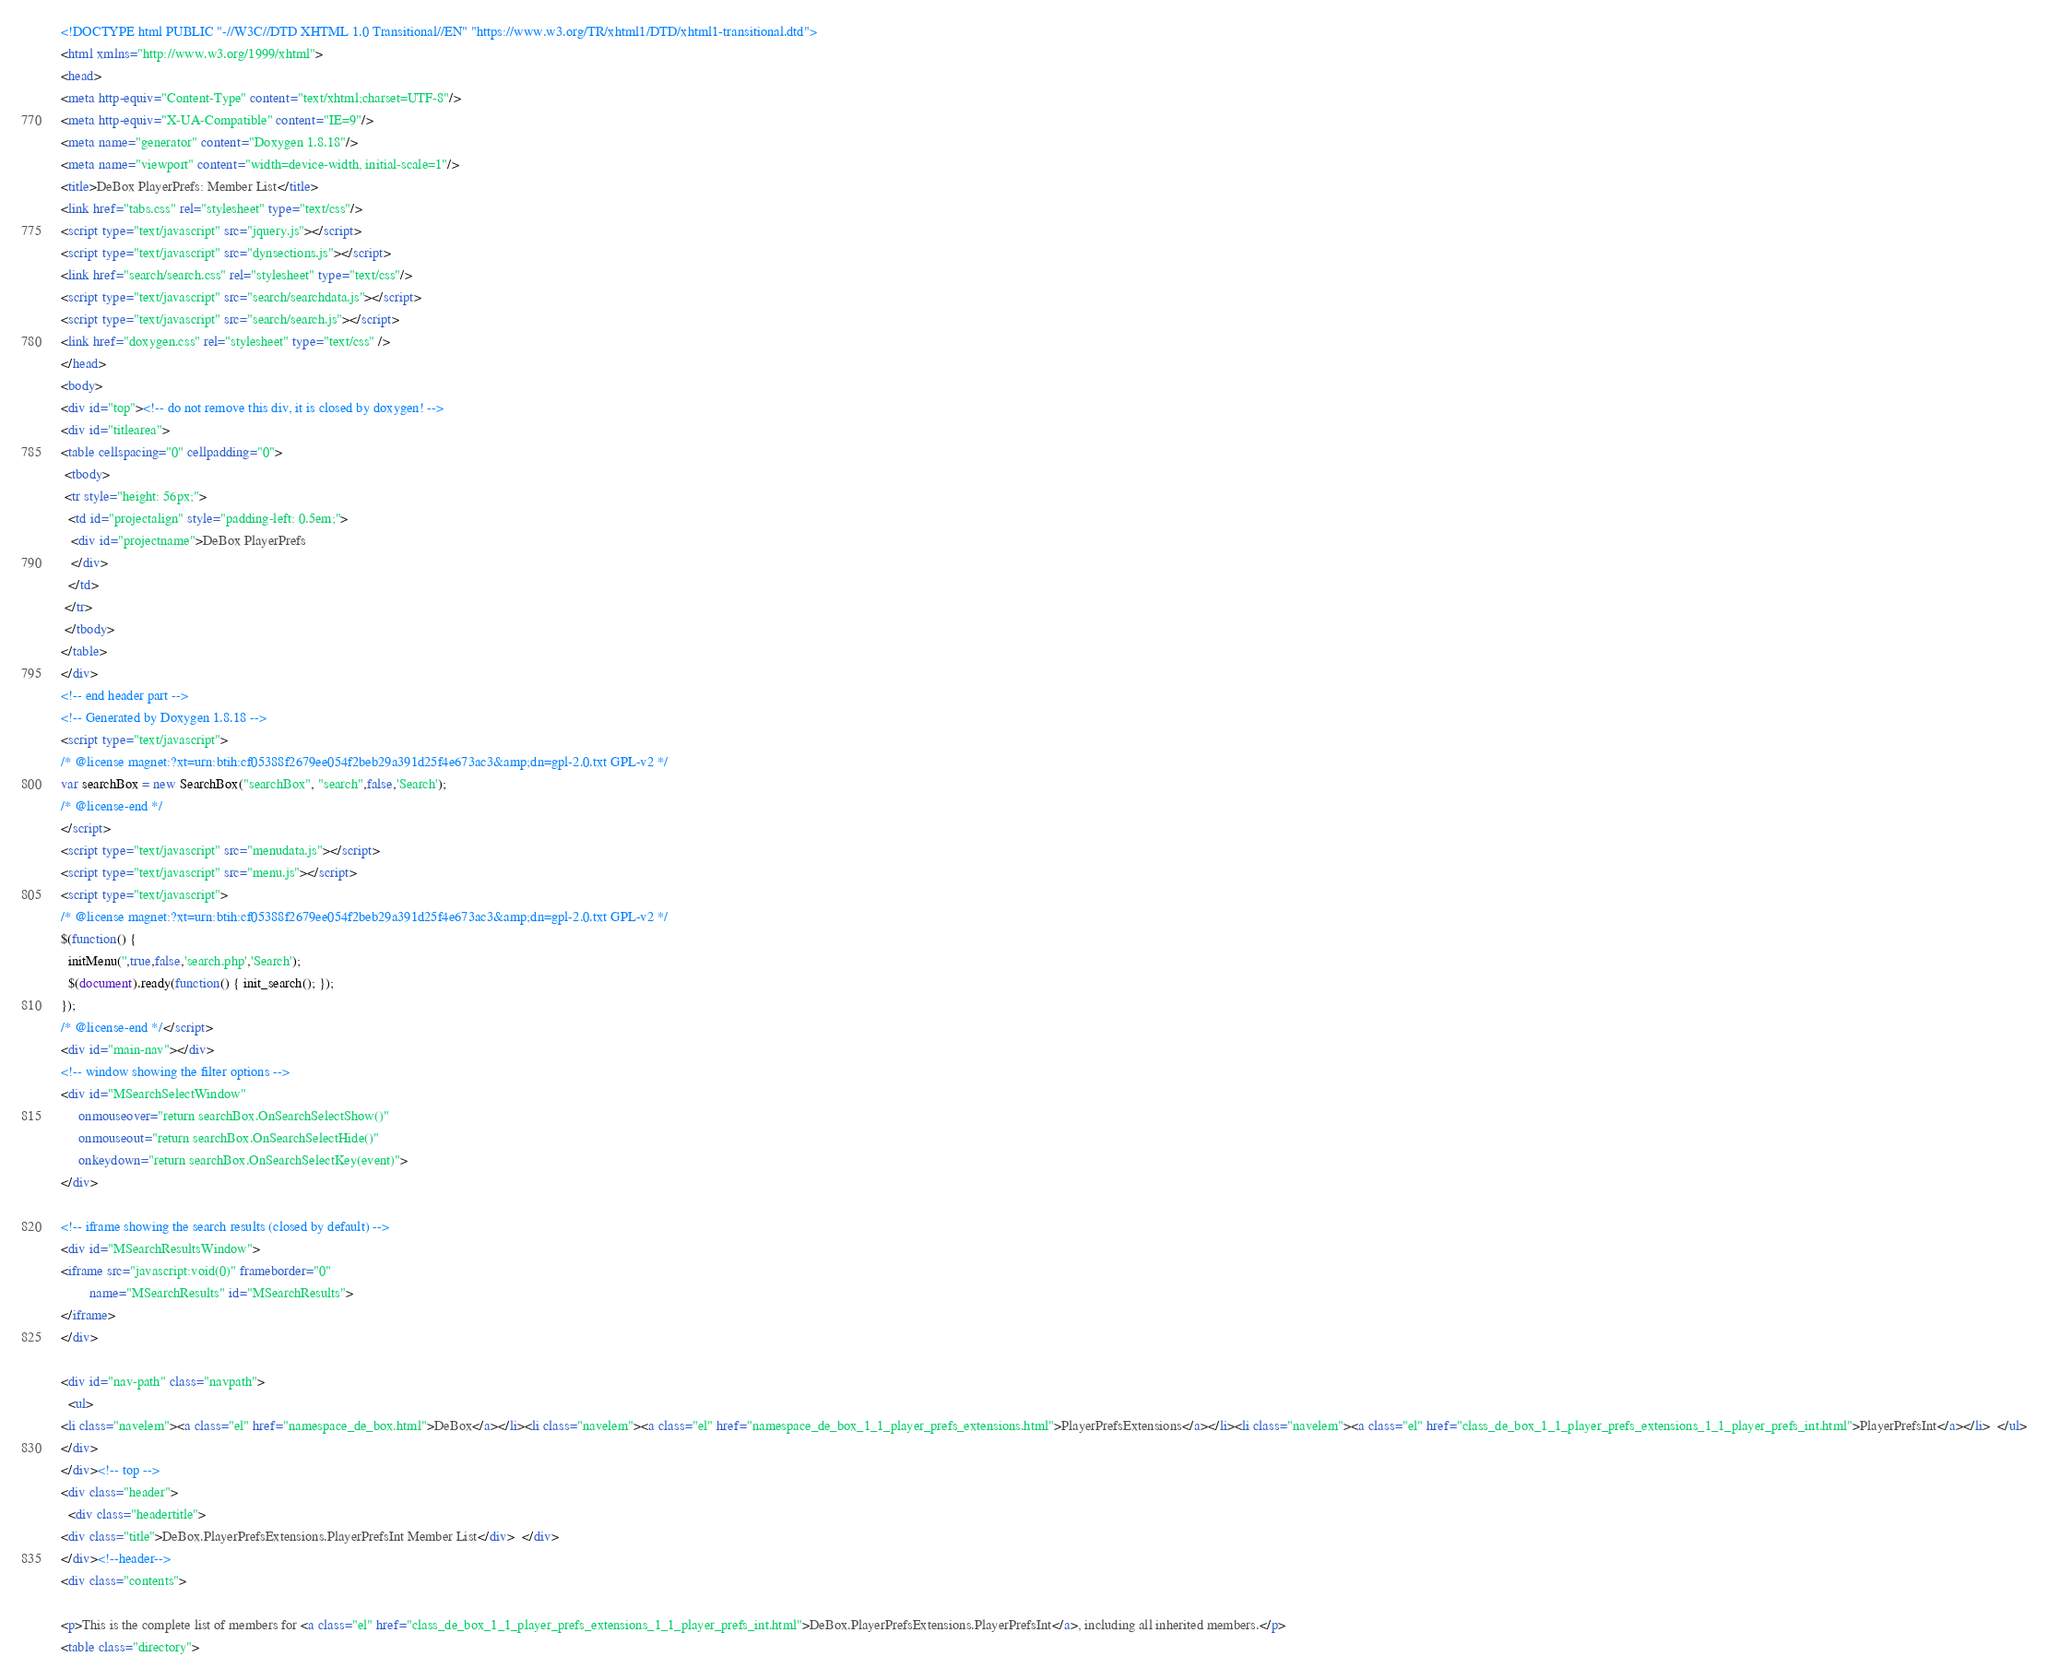Convert code to text. <code><loc_0><loc_0><loc_500><loc_500><_HTML_><!DOCTYPE html PUBLIC "-//W3C//DTD XHTML 1.0 Transitional//EN" "https://www.w3.org/TR/xhtml1/DTD/xhtml1-transitional.dtd">
<html xmlns="http://www.w3.org/1999/xhtml">
<head>
<meta http-equiv="Content-Type" content="text/xhtml;charset=UTF-8"/>
<meta http-equiv="X-UA-Compatible" content="IE=9"/>
<meta name="generator" content="Doxygen 1.8.18"/>
<meta name="viewport" content="width=device-width, initial-scale=1"/>
<title>DeBox PlayerPrefs: Member List</title>
<link href="tabs.css" rel="stylesheet" type="text/css"/>
<script type="text/javascript" src="jquery.js"></script>
<script type="text/javascript" src="dynsections.js"></script>
<link href="search/search.css" rel="stylesheet" type="text/css"/>
<script type="text/javascript" src="search/searchdata.js"></script>
<script type="text/javascript" src="search/search.js"></script>
<link href="doxygen.css" rel="stylesheet" type="text/css" />
</head>
<body>
<div id="top"><!-- do not remove this div, it is closed by doxygen! -->
<div id="titlearea">
<table cellspacing="0" cellpadding="0">
 <tbody>
 <tr style="height: 56px;">
  <td id="projectalign" style="padding-left: 0.5em;">
   <div id="projectname">DeBox PlayerPrefs
   </div>
  </td>
 </tr>
 </tbody>
</table>
</div>
<!-- end header part -->
<!-- Generated by Doxygen 1.8.18 -->
<script type="text/javascript">
/* @license magnet:?xt=urn:btih:cf05388f2679ee054f2beb29a391d25f4e673ac3&amp;dn=gpl-2.0.txt GPL-v2 */
var searchBox = new SearchBox("searchBox", "search",false,'Search');
/* @license-end */
</script>
<script type="text/javascript" src="menudata.js"></script>
<script type="text/javascript" src="menu.js"></script>
<script type="text/javascript">
/* @license magnet:?xt=urn:btih:cf05388f2679ee054f2beb29a391d25f4e673ac3&amp;dn=gpl-2.0.txt GPL-v2 */
$(function() {
  initMenu('',true,false,'search.php','Search');
  $(document).ready(function() { init_search(); });
});
/* @license-end */</script>
<div id="main-nav"></div>
<!-- window showing the filter options -->
<div id="MSearchSelectWindow"
     onmouseover="return searchBox.OnSearchSelectShow()"
     onmouseout="return searchBox.OnSearchSelectHide()"
     onkeydown="return searchBox.OnSearchSelectKey(event)">
</div>

<!-- iframe showing the search results (closed by default) -->
<div id="MSearchResultsWindow">
<iframe src="javascript:void(0)" frameborder="0" 
        name="MSearchResults" id="MSearchResults">
</iframe>
</div>

<div id="nav-path" class="navpath">
  <ul>
<li class="navelem"><a class="el" href="namespace_de_box.html">DeBox</a></li><li class="navelem"><a class="el" href="namespace_de_box_1_1_player_prefs_extensions.html">PlayerPrefsExtensions</a></li><li class="navelem"><a class="el" href="class_de_box_1_1_player_prefs_extensions_1_1_player_prefs_int.html">PlayerPrefsInt</a></li>  </ul>
</div>
</div><!-- top -->
<div class="header">
  <div class="headertitle">
<div class="title">DeBox.PlayerPrefsExtensions.PlayerPrefsInt Member List</div>  </div>
</div><!--header-->
<div class="contents">

<p>This is the complete list of members for <a class="el" href="class_de_box_1_1_player_prefs_extensions_1_1_player_prefs_int.html">DeBox.PlayerPrefsExtensions.PlayerPrefsInt</a>, including all inherited members.</p>
<table class="directory"></code> 